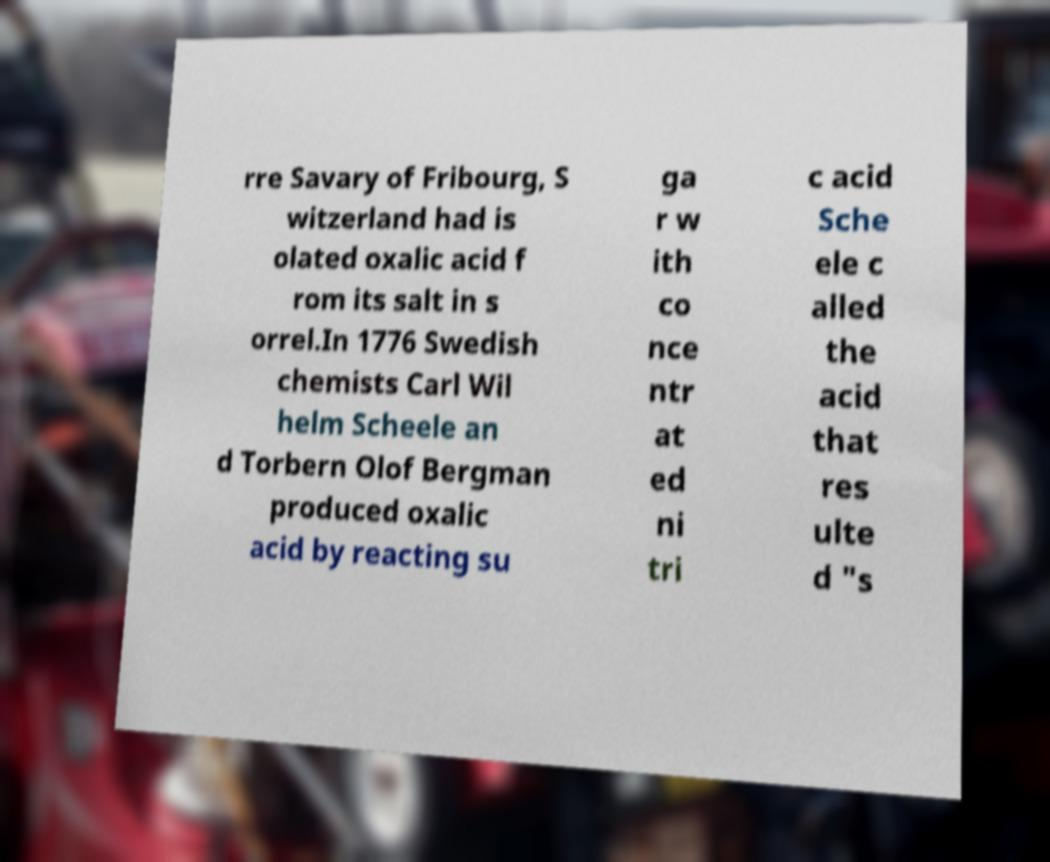Please identify and transcribe the text found in this image. rre Savary of Fribourg, S witzerland had is olated oxalic acid f rom its salt in s orrel.In 1776 Swedish chemists Carl Wil helm Scheele an d Torbern Olof Bergman produced oxalic acid by reacting su ga r w ith co nce ntr at ed ni tri c acid Sche ele c alled the acid that res ulte d "s 